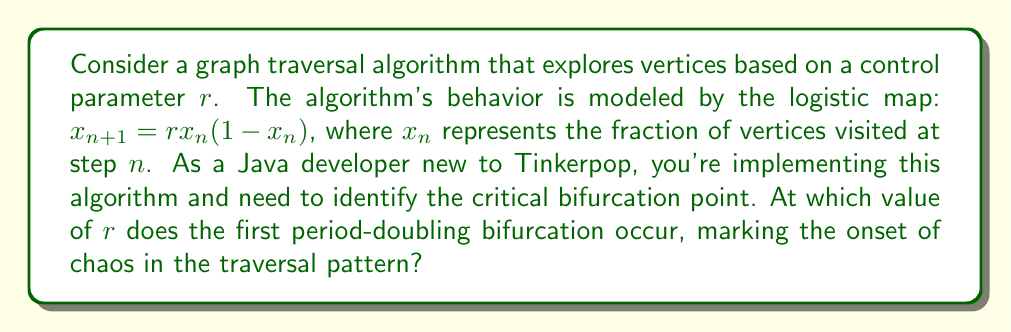Solve this math problem. To find the first period-doubling bifurcation point in the logistic map, we need to follow these steps:

1. The logistic map is given by the equation:
   $$x_{n+1} = rx_n(1-x_n)$$

2. At equilibrium, $x_{n+1} = x_n = x^*$, so we can write:
   $$x^* = rx^*(1-x^*)$$

3. Solving this equation, we get two fixed points:
   $$x^* = 0$$ and $$x^* = 1 - \frac{1}{r}$$

4. The non-zero fixed point $x^* = 1 - \frac{1}{r}$ is stable for $1 < r < 3$.

5. To find the bifurcation point, we need to analyze the stability of this fixed point. The derivative of the logistic map at the fixed point is:
   $$f'(x^*) = r(1-2x^*)$$

6. Substituting $x^* = 1 - \frac{1}{r}$, we get:
   $$f'(x^*) = r(1-2(1-\frac{1}{r})) = r(2\frac{1}{r}-1) = 2-r$$

7. The fixed point loses stability when $|f'(x^*)| = 1$. In this case:
   $$|2-r| = 1$$

8. Solving this equation:
   $$2-r = -1$$ (since we know $r > 1$)
   $$r = 3$$

Therefore, the first period-doubling bifurcation occurs at $r = 3$, marking the onset of chaos in the graph traversal algorithm.
Answer: $r = 3$ 